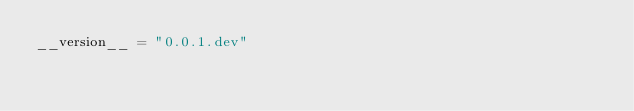Convert code to text. <code><loc_0><loc_0><loc_500><loc_500><_Python_>__version__ = "0.0.1.dev"
</code> 